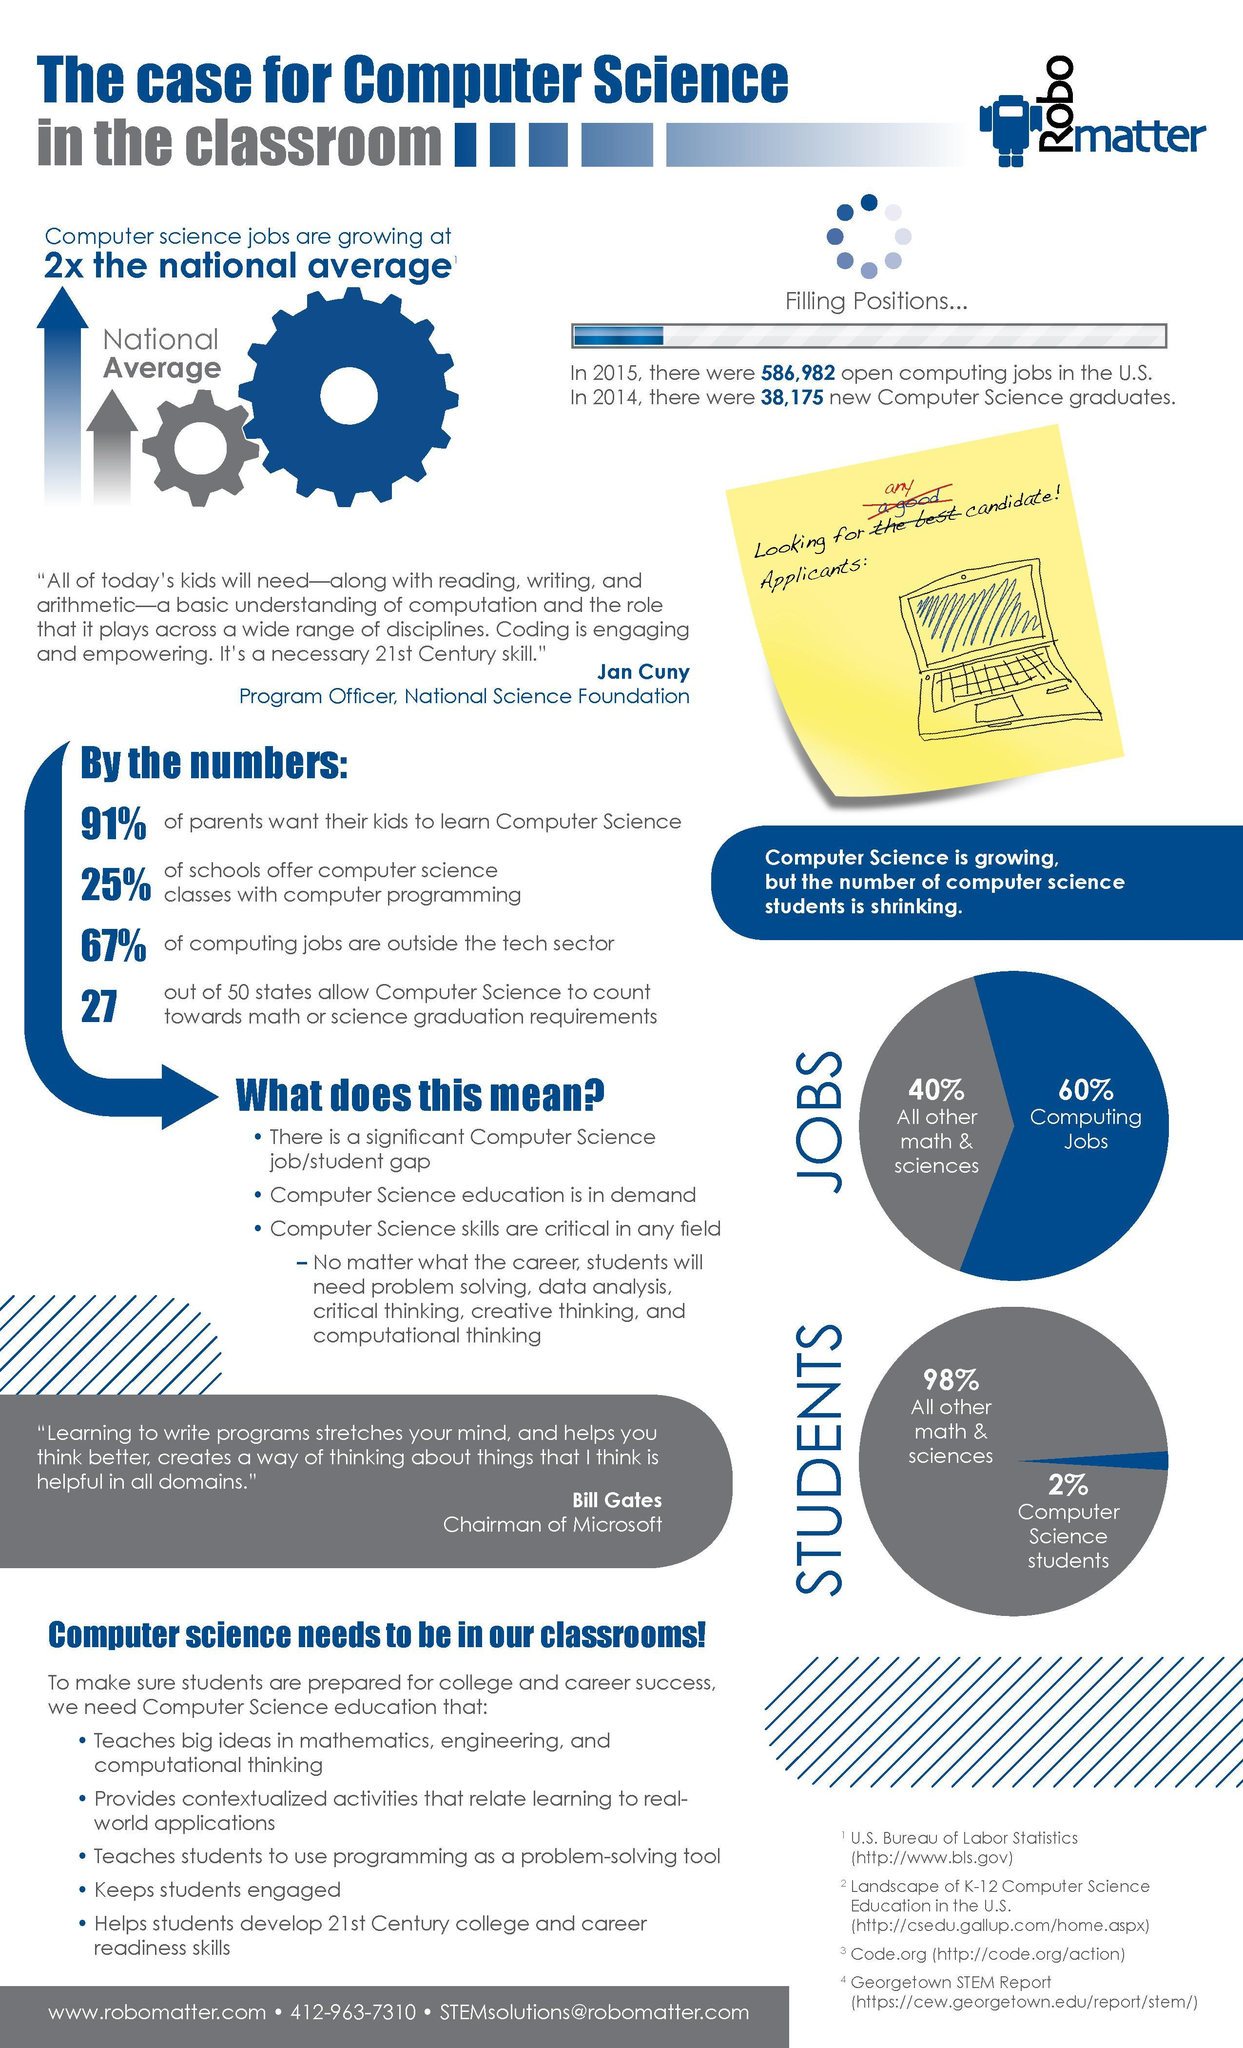What percentage of parents don't want their kids to learn computer science?
Answer the question with a short phrase. 9% What percentage of computing jobs are not outside the tech sector? 33% 